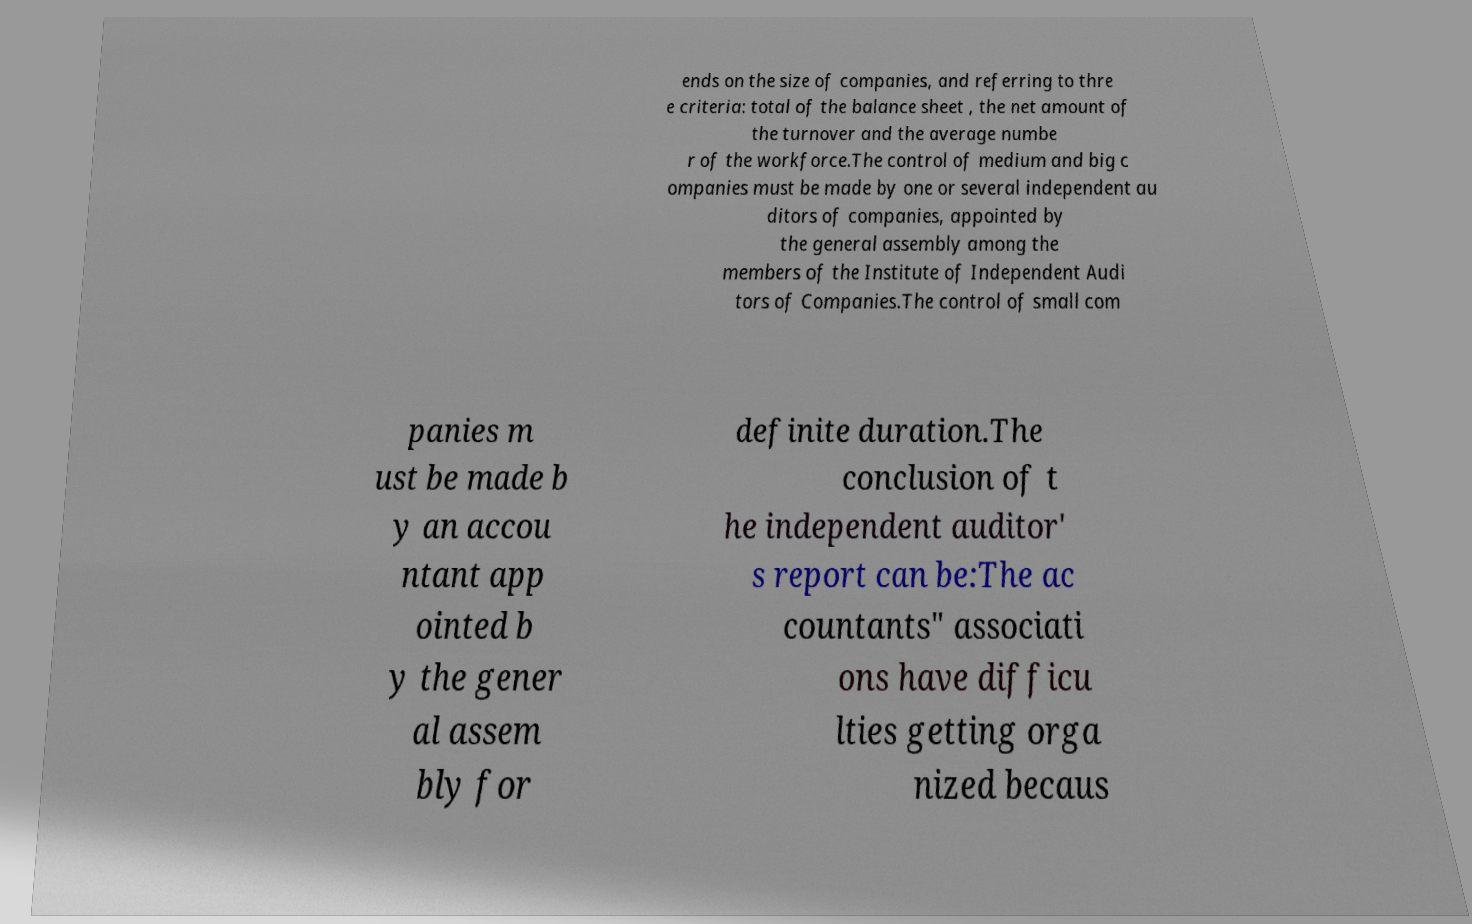Please read and relay the text visible in this image. What does it say? ends on the size of companies, and referring to thre e criteria: total of the balance sheet , the net amount of the turnover and the average numbe r of the workforce.The control of medium and big c ompanies must be made by one or several independent au ditors of companies, appointed by the general assembly among the members of the Institute of Independent Audi tors of Companies.The control of small com panies m ust be made b y an accou ntant app ointed b y the gener al assem bly for definite duration.The conclusion of t he independent auditor' s report can be:The ac countants" associati ons have difficu lties getting orga nized becaus 